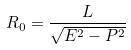<formula> <loc_0><loc_0><loc_500><loc_500>R _ { 0 } = \frac { L } { \sqrt { E ^ { 2 } - P ^ { 2 } } }</formula> 